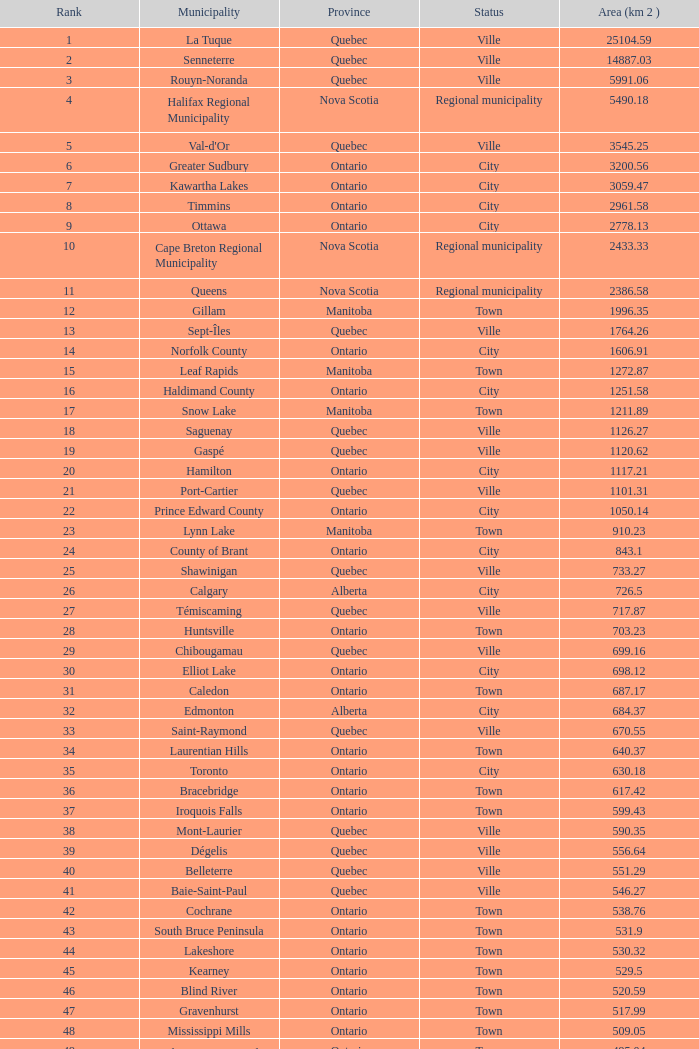What's the total of Rank that has an Area (KM 2) of 1050.14? 22.0. 